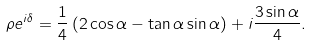<formula> <loc_0><loc_0><loc_500><loc_500>\rho e ^ { i \delta } = \frac { 1 } { 4 } \left ( 2 \cos \alpha - \tan \alpha \sin \alpha \right ) + i \frac { 3 \sin \alpha } { 4 } .</formula> 